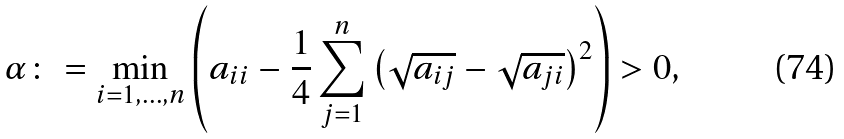<formula> <loc_0><loc_0><loc_500><loc_500>\alpha \colon = \min _ { i = 1 , \dots , n } \left ( a _ { i i } - \frac { 1 } { 4 } \sum _ { j = 1 } ^ { n } \left ( \sqrt { a _ { i j } } - \sqrt { a _ { j i } } \right ) ^ { 2 } \right ) > 0 ,</formula> 